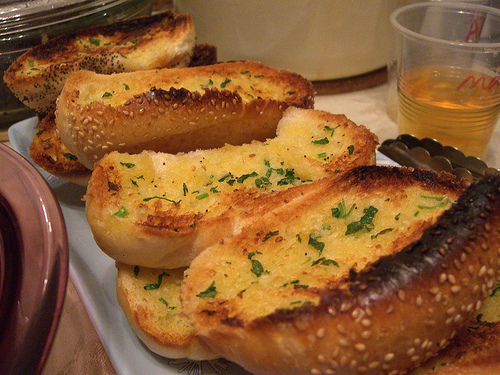<image>
Can you confirm if the glass is in the burger? No. The glass is not contained within the burger. These objects have a different spatial relationship. 